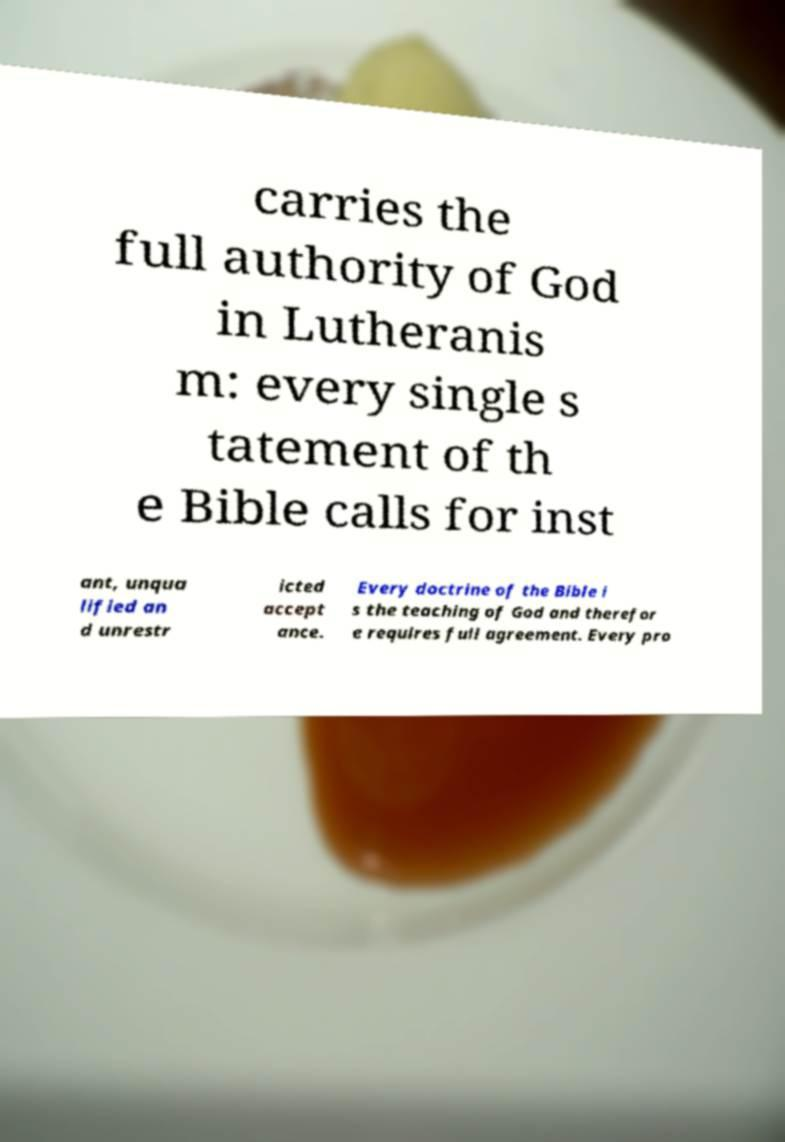Please read and relay the text visible in this image. What does it say? carries the full authority of God in Lutheranis m: every single s tatement of th e Bible calls for inst ant, unqua lified an d unrestr icted accept ance. Every doctrine of the Bible i s the teaching of God and therefor e requires full agreement. Every pro 